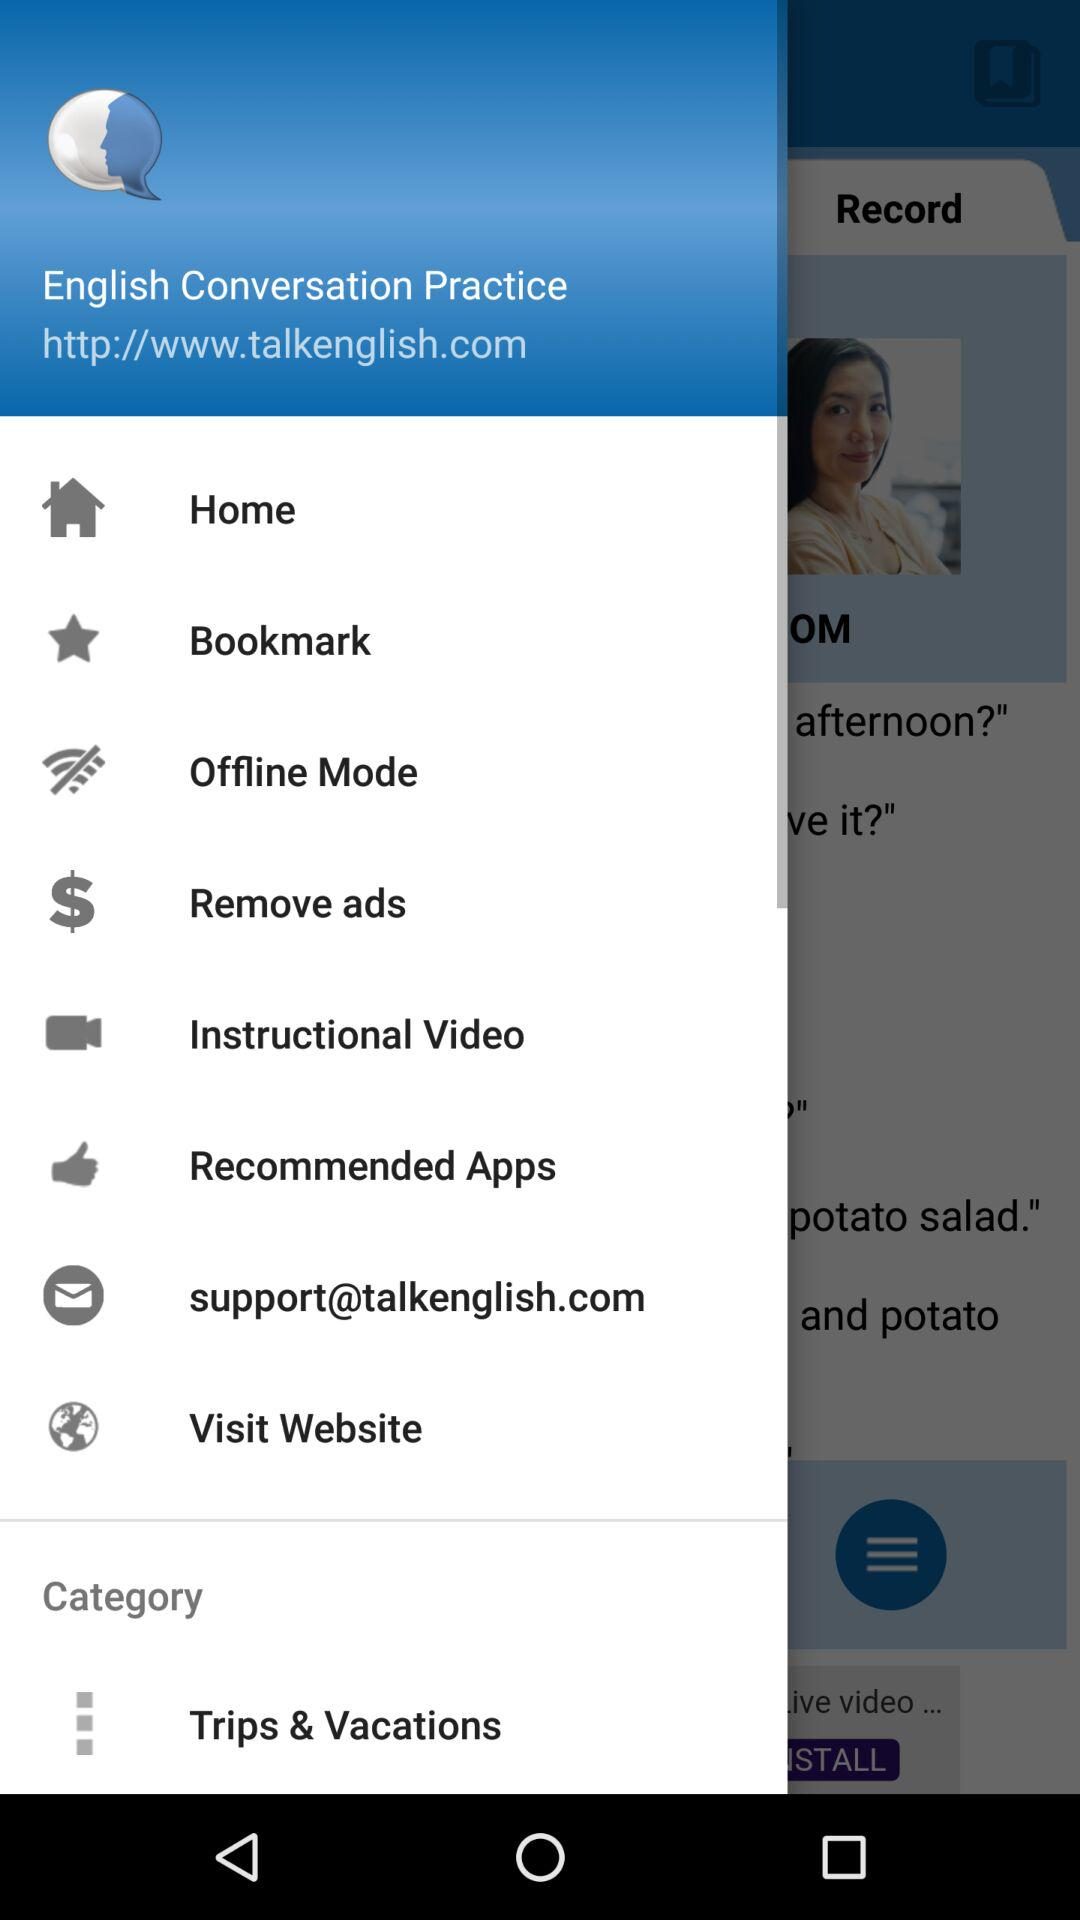What's the email address for support? The email address for support is support@talkenglish.com. 